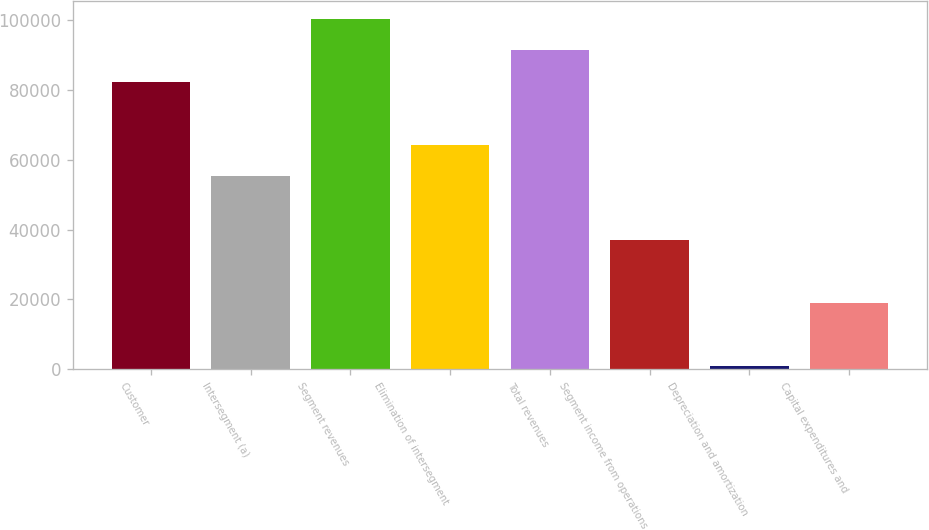<chart> <loc_0><loc_0><loc_500><loc_500><bar_chart><fcel>Customer<fcel>Intersegment (a)<fcel>Segment revenues<fcel>Elimination of intersegment<fcel>Total revenues<fcel>Segment income from operations<fcel>Depreciation and amortization<fcel>Capital expenditures and<nl><fcel>82237<fcel>55236<fcel>100325<fcel>64280<fcel>91281<fcel>37148<fcel>972<fcel>19060<nl></chart> 